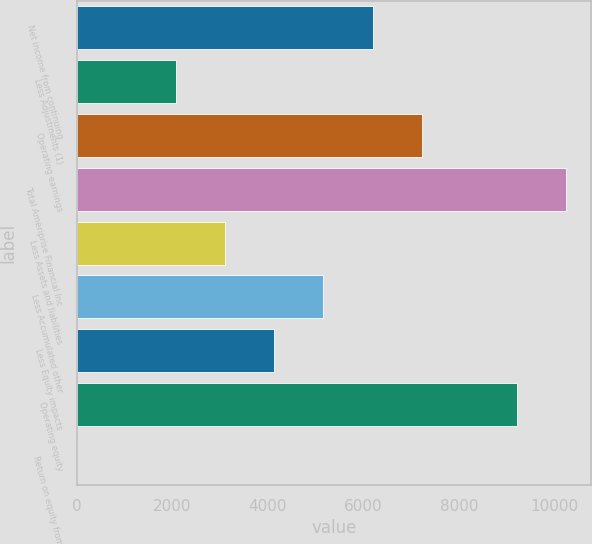Convert chart to OTSL. <chart><loc_0><loc_0><loc_500><loc_500><bar_chart><fcel>Net income from continuing<fcel>Less Adjustments (1)<fcel>Operating earnings<fcel>Total Ameriprise Financial Inc<fcel>Less Assets and liabilities<fcel>Less Accumulated other<fcel>Less Equity impacts<fcel>Operating equity<fcel>Return on equity from<nl><fcel>6190.04<fcel>2071.08<fcel>7219.78<fcel>10241.7<fcel>3100.82<fcel>5160.3<fcel>4130.56<fcel>9212<fcel>11.6<nl></chart> 